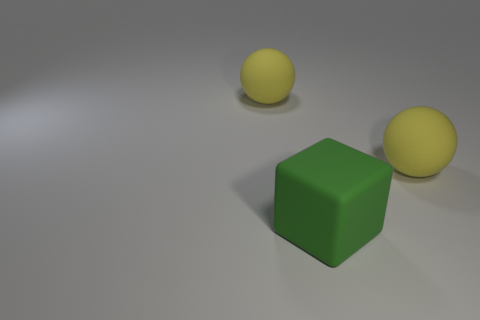What number of things are either big rubber objects on the left side of the big green matte block or small metal balls?
Ensure brevity in your answer.  1. The yellow thing to the right of the large matte ball left of the big cube is made of what material?
Keep it short and to the point. Rubber. What number of things are large yellow balls on the right side of the block or matte balls right of the big green block?
Keep it short and to the point. 1. Are there more matte things than yellow objects?
Provide a short and direct response. Yes. Does the sphere that is right of the matte cube have the same material as the green object?
Your answer should be compact. Yes. Is the number of rubber balls less than the number of large green objects?
Offer a very short reply. No. Is there a big thing left of the yellow object in front of the big yellow sphere that is left of the big rubber block?
Your answer should be compact. Yes. Are there more big yellow rubber balls behind the green cube than tiny red cubes?
Ensure brevity in your answer.  Yes. There is a matte thing that is on the right side of the green rubber block; does it have the same color as the big block?
Provide a succinct answer. No. What color is the big object that is behind the matte sphere that is in front of the yellow rubber thing on the left side of the large green object?
Make the answer very short. Yellow. 